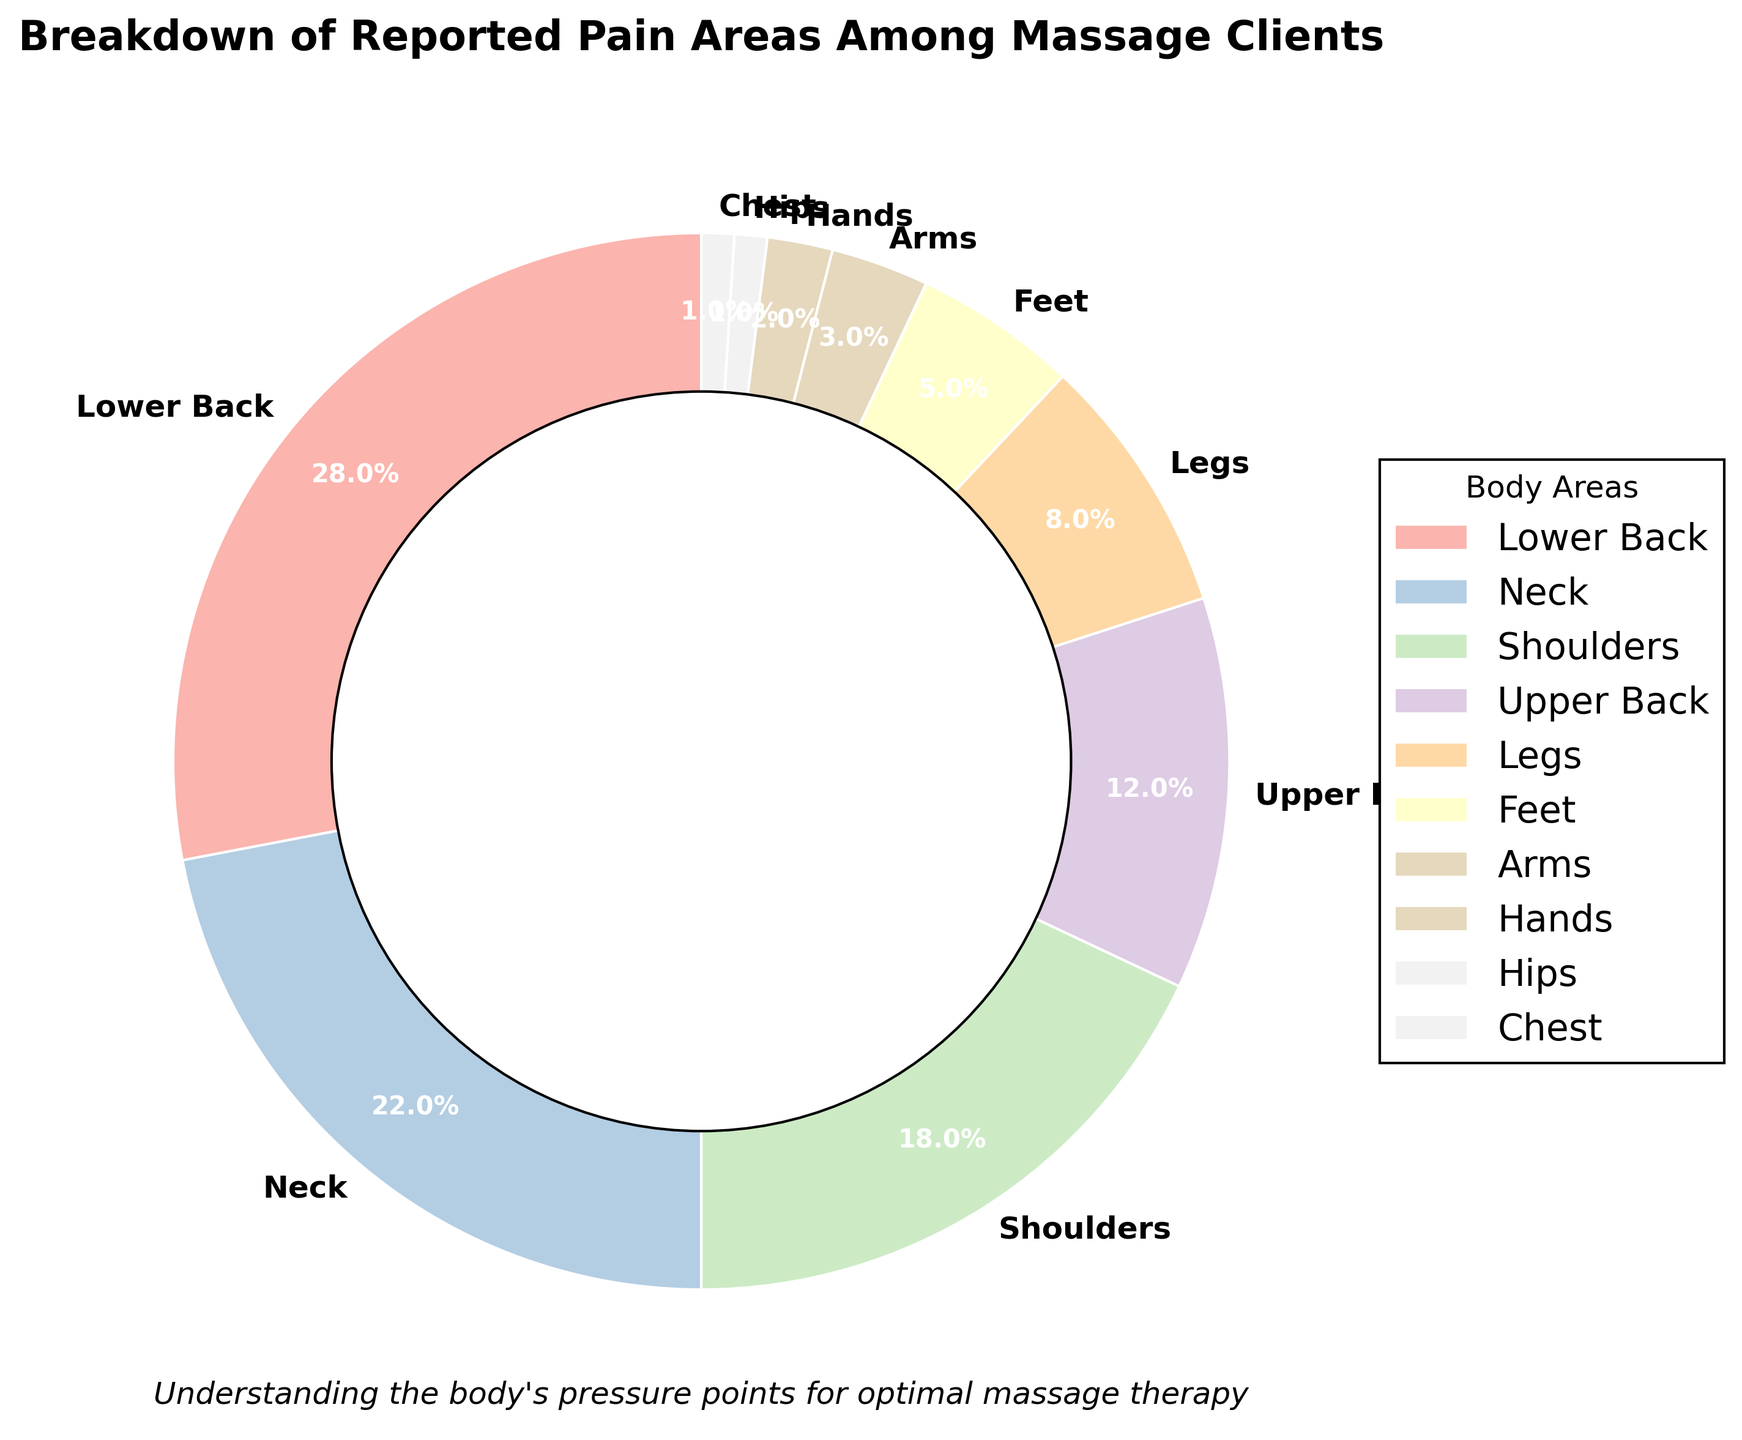Which area reports the highest percentage of pain? The chart shows the breakdown of reported pain areas, with each section labeled with the respective percentage. The largest section is labeled "Lower Back" with 28%.
Answer: Lower Back What is the combined percentage of clients reporting pain in the neck and shoulders? Sum the percentages for Neck (22%) and Shoulders (18%) by referring to the chart. 22% + 18% = 40%
Answer: 40% Which area reports the least percentage of pain? Look for the smallest labeled section in the pie chart. The smallest section is the Hips and Chest, each with 1%.
Answer: Hips and Chest How much more frequently is lower back pain reported than foot pain? Find the difference between the percentages for Lower Back (28%) and Feet (5%). 28% - 5% = 23%
Answer: 23% Which two areas combined have the same percentage as the lower back alone? Check the chart for combinations that add up to 28%. The combined percentages up to 28% are Neck (22%) and Feet (5%) because 22% + 5% = 27%, which is close to the largest percentage of Lower Back alone (28%).
Answer: Neck and Feet What is the total percentage of clients reporting pain in their upper body areas (Neck, Shoulders, Upper Back, and Chest)? Sum the percentages for the upper body areas: Neck (22%), Shoulders (18%), Upper Back (12%), and Chest (1%). 22% + 18% + 12% + 1% = 53%
Answer: 53% Which areas report a lower percentage of pain than the upper back? Compare the percentages: Upper Back (12%) with Legs (8%), Feet (5%), Arms (3%), Hands (2%), Hips (1%), Chest (1%). All these areas have lower percentages than Upper Back's 12%.
Answer: Legs, Feet, Arms, Hands, Hips, Chest What percentage of clients report pain in their legs compared to those reporting pain in their feet? The percentage for Legs is 8% and for Feet is 5%. Compare these two values to see which is larger and by how much.
Answer: 8% vs 5% What is the difference in the percentage of clients reporting arm pain and those reporting hand pain? Subtract the percentage of Hands (2%) from Arms (3%) by referring to the chart. 3% - 2% = 1%
Answer: 1% Which body area has a percentage that is exactly half of Shoulder pain reports? Shoulder pain reports stand at 18%. If we half it, we get 9%. By checking the chart, no area exactly matches 9%, but Legs is closest at 8%.
Answer: No exact match, closest is Legs 